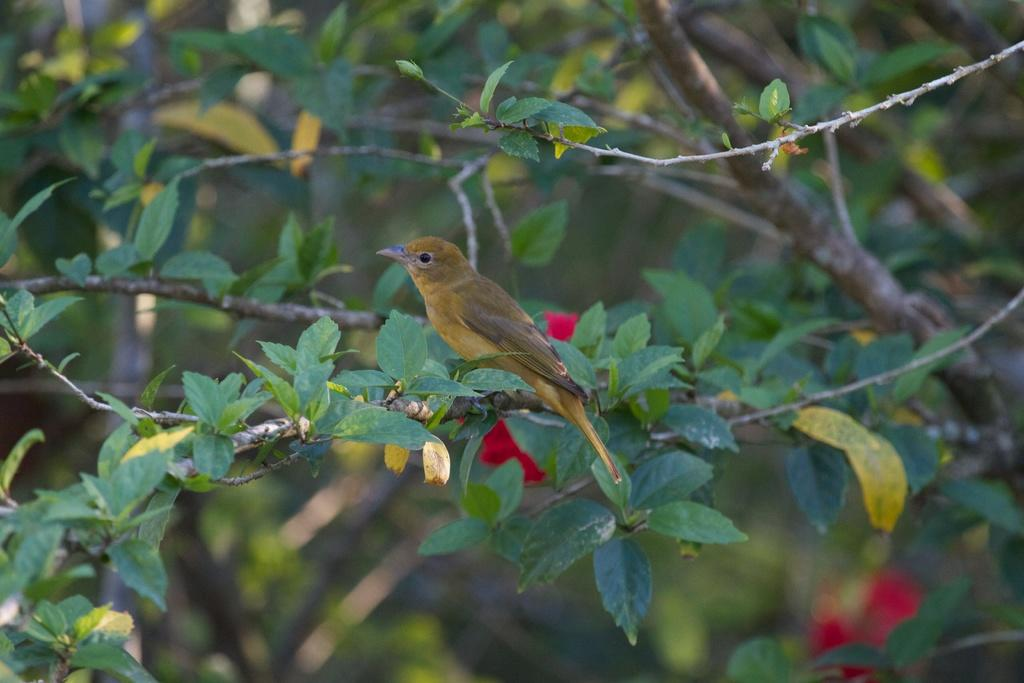What type of vegetation can be seen in the image? There are branches with leaves in the image. Is there any wildlife present in the image? Yes, there is a bird on one of the branches. How would you describe the background of the image? The background of the image is blurred. How many girls are present in the image discussing their theories? There are no girls present in the image, nor is there any discussion about theories. 